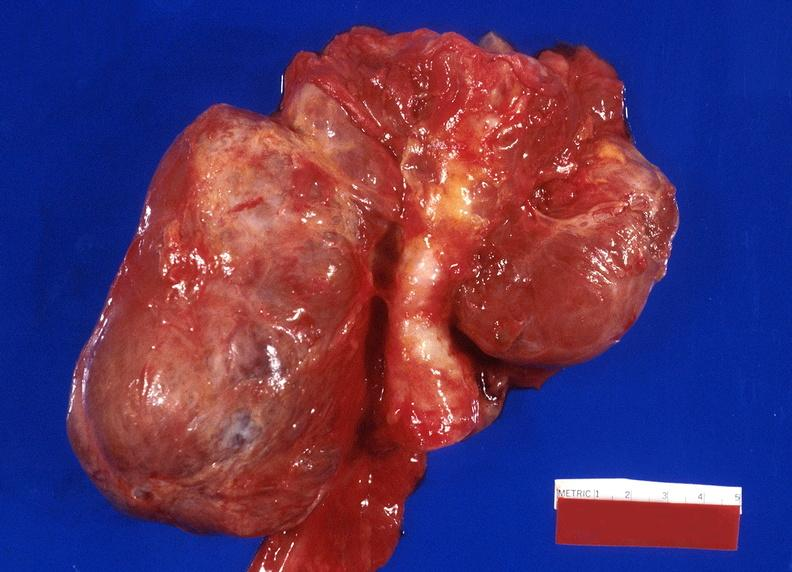s endocrine present?
Answer the question using a single word or phrase. Yes 